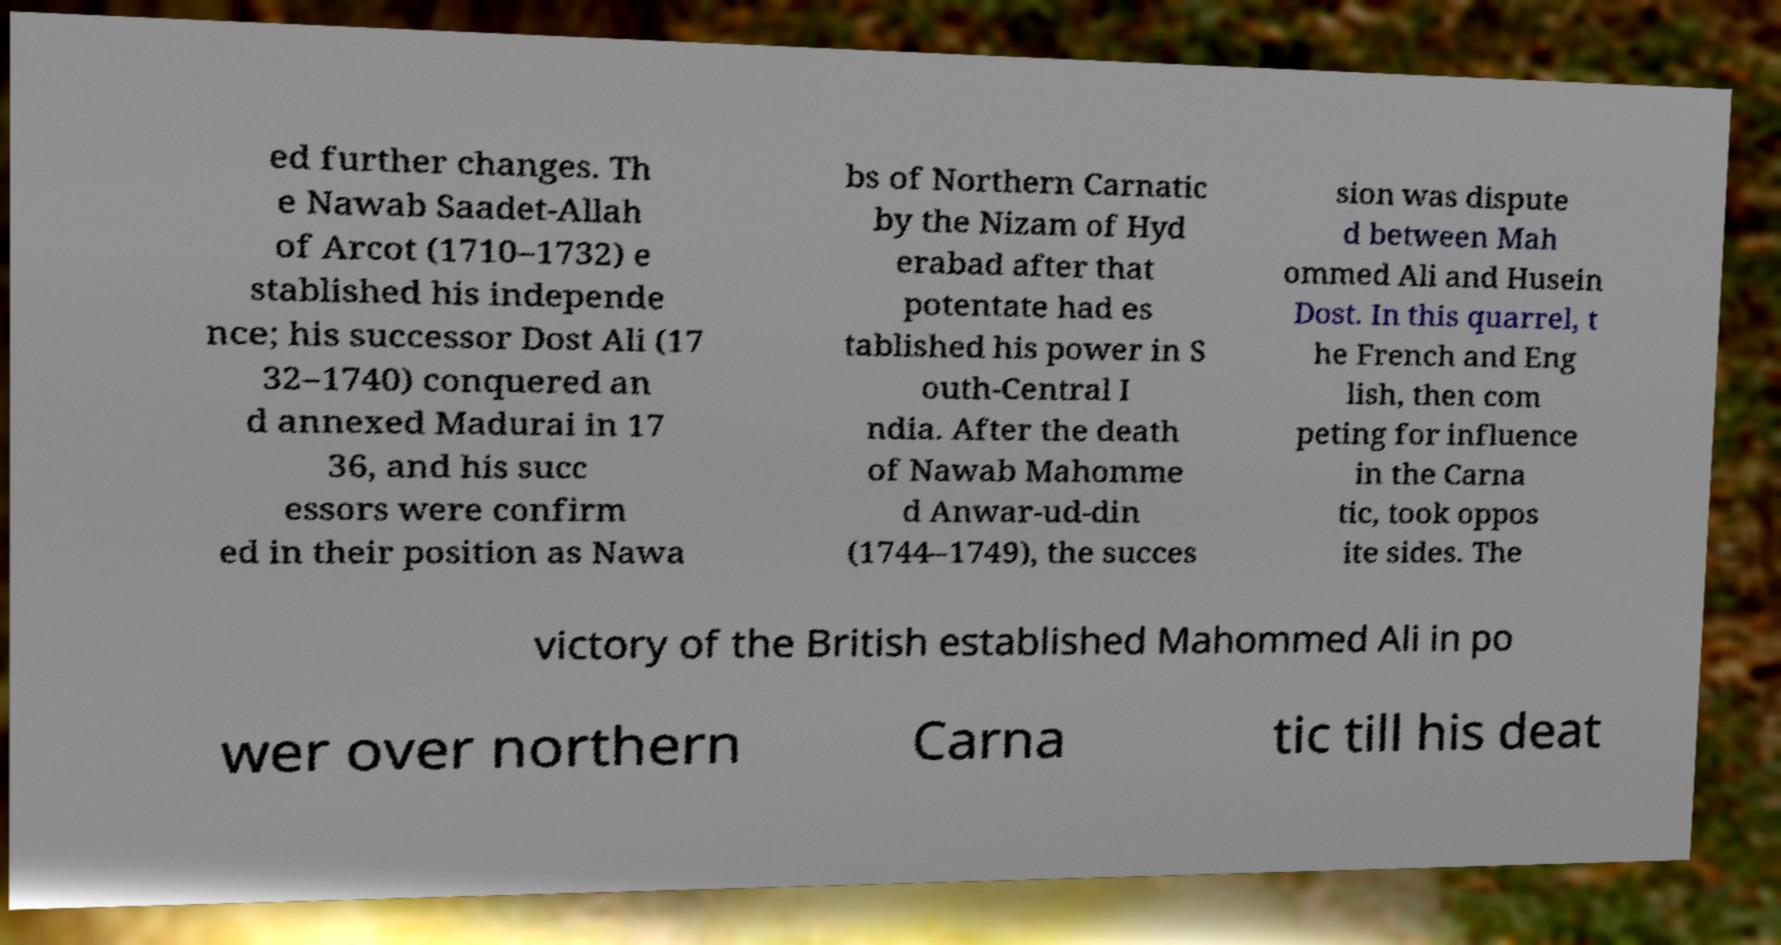For documentation purposes, I need the text within this image transcribed. Could you provide that? ed further changes. Th e Nawab Saadet-Allah of Arcot (1710–1732) e stablished his independe nce; his successor Dost Ali (17 32–1740) conquered an d annexed Madurai in 17 36, and his succ essors were confirm ed in their position as Nawa bs of Northern Carnatic by the Nizam of Hyd erabad after that potentate had es tablished his power in S outh-Central I ndia. After the death of Nawab Mahomme d Anwar-ud-din (1744–1749), the succes sion was dispute d between Mah ommed Ali and Husein Dost. In this quarrel, t he French and Eng lish, then com peting for influence in the Carna tic, took oppos ite sides. The victory of the British established Mahommed Ali in po wer over northern Carna tic till his deat 